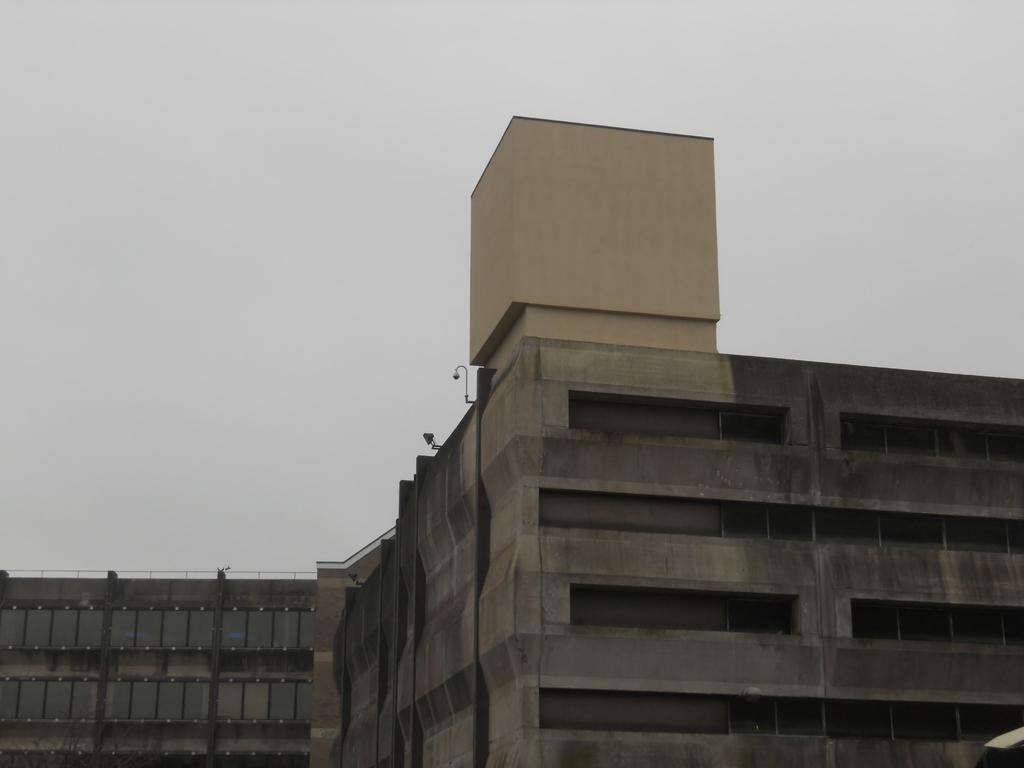What type of structure is in the image? There is a building in the image. What colors are used on the building? The building has cream, gray, and black colors. What can be seen in the background of the image? The sky is visible in the background of the image. What is the color of the sky in the image? The color of the sky is white. Can you see a kitten adjusting its uncle's tie in the image? No, there is no kitten or person adjusting a tie present in the image. 